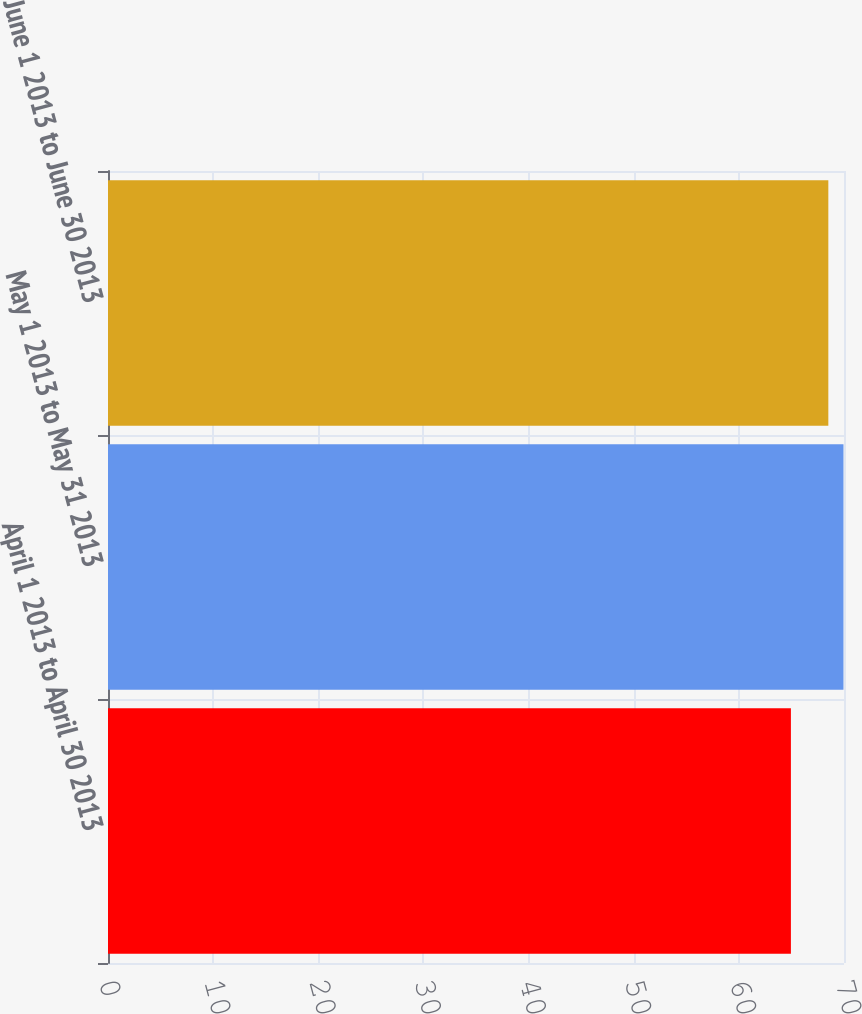Convert chart to OTSL. <chart><loc_0><loc_0><loc_500><loc_500><bar_chart><fcel>April 1 2013 to April 30 2013<fcel>May 1 2013 to May 31 2013<fcel>June 1 2013 to June 30 2013<nl><fcel>64.95<fcel>69.95<fcel>68.51<nl></chart> 